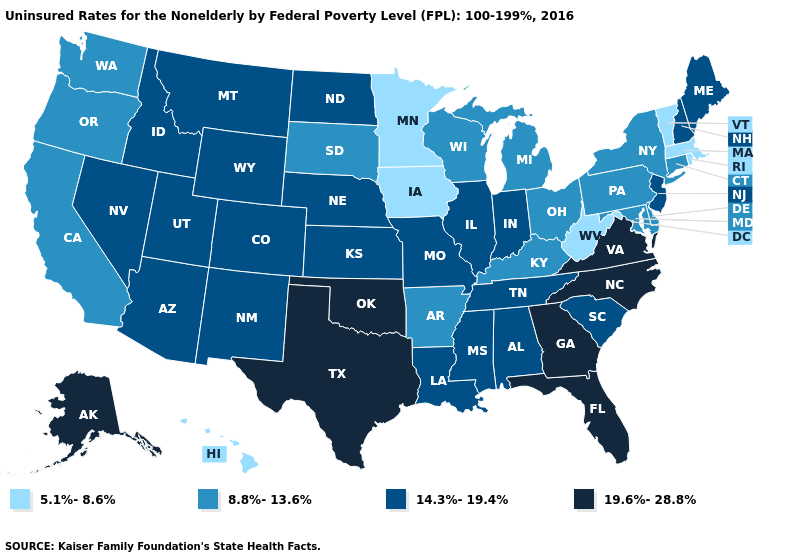Which states hav the highest value in the West?
Quick response, please. Alaska. Name the states that have a value in the range 19.6%-28.8%?
Keep it brief. Alaska, Florida, Georgia, North Carolina, Oklahoma, Texas, Virginia. What is the lowest value in the West?
Keep it brief. 5.1%-8.6%. What is the value of Iowa?
Write a very short answer. 5.1%-8.6%. What is the lowest value in the USA?
Keep it brief. 5.1%-8.6%. What is the value of Kansas?
Write a very short answer. 14.3%-19.4%. Which states have the lowest value in the South?
Answer briefly. West Virginia. What is the value of Texas?
Concise answer only. 19.6%-28.8%. What is the lowest value in states that border California?
Quick response, please. 8.8%-13.6%. Name the states that have a value in the range 8.8%-13.6%?
Answer briefly. Arkansas, California, Connecticut, Delaware, Kentucky, Maryland, Michigan, New York, Ohio, Oregon, Pennsylvania, South Dakota, Washington, Wisconsin. What is the value of Michigan?
Be succinct. 8.8%-13.6%. What is the lowest value in the USA?
Write a very short answer. 5.1%-8.6%. Does Massachusetts have the lowest value in the USA?
Be succinct. Yes. What is the value of California?
Concise answer only. 8.8%-13.6%. 